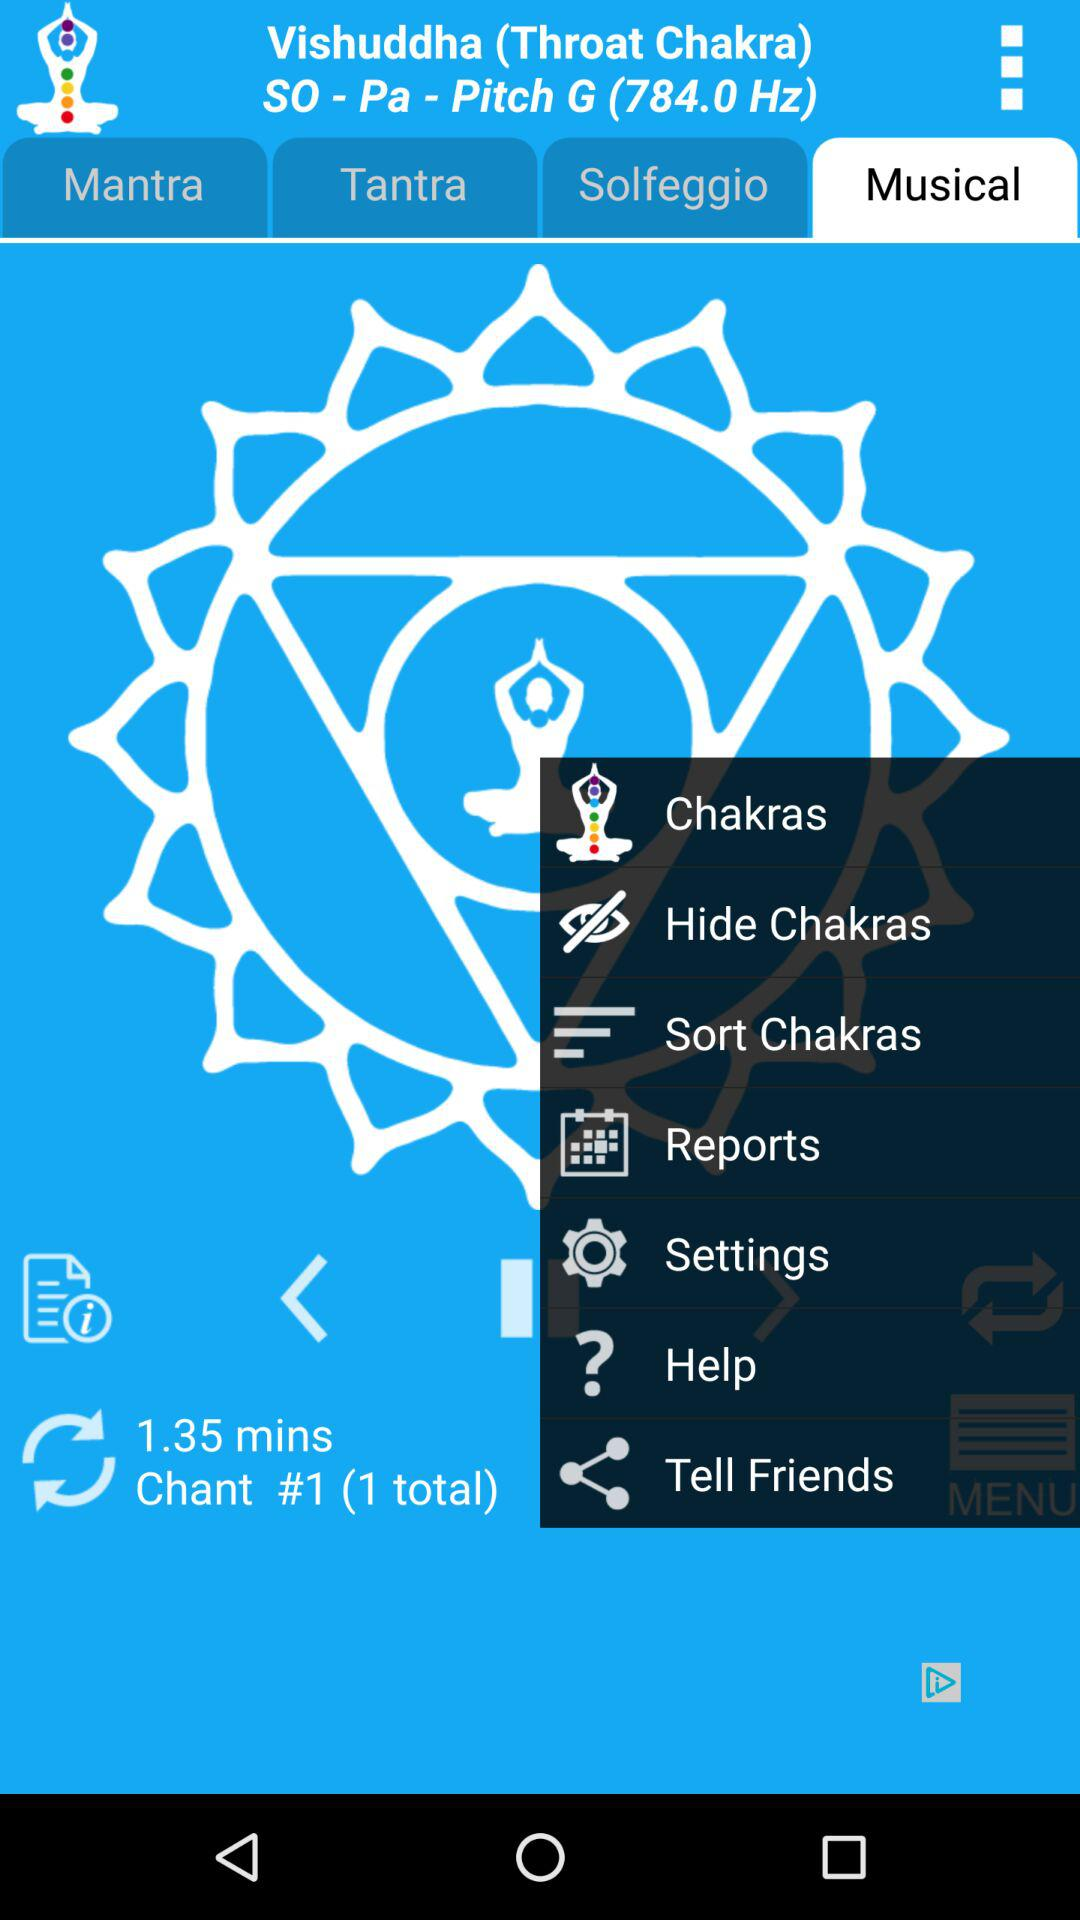What is the application name? The application name is "Chakra Meditation". 